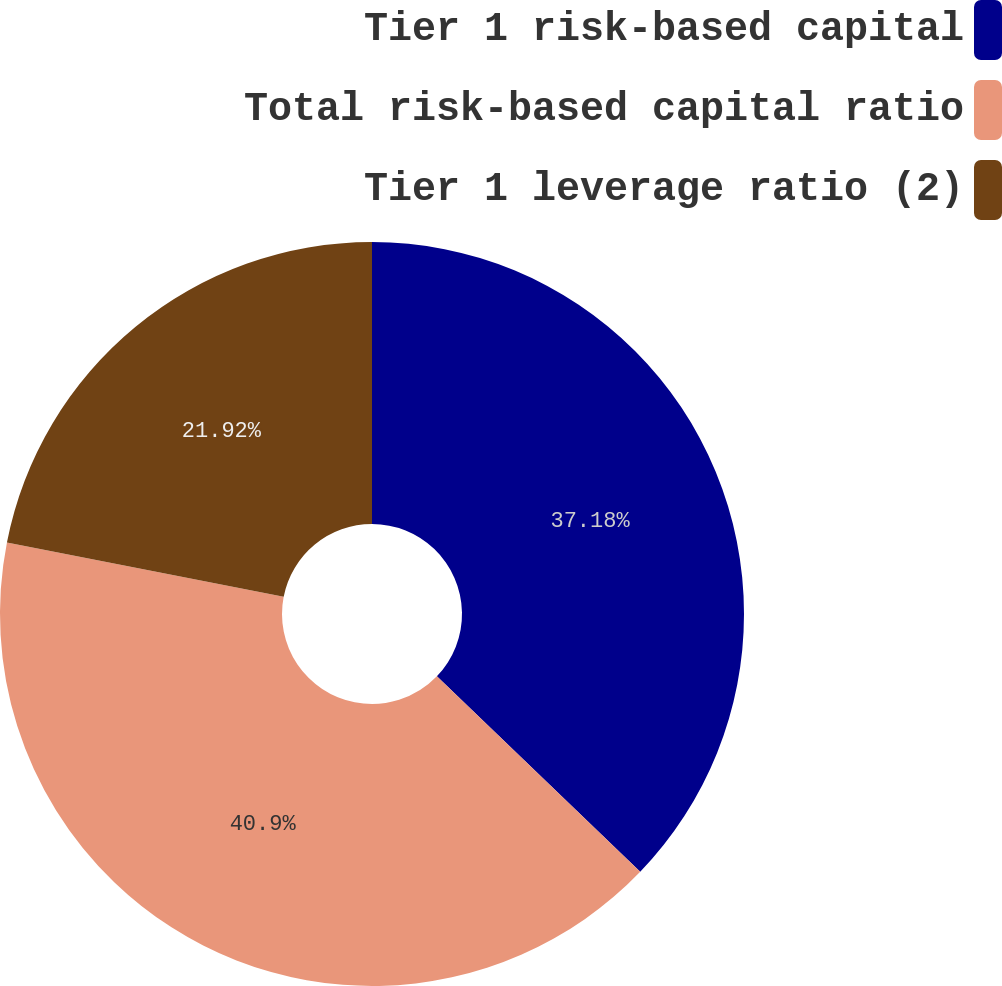<chart> <loc_0><loc_0><loc_500><loc_500><pie_chart><fcel>Tier 1 risk-based capital<fcel>Total risk-based capital ratio<fcel>Tier 1 leverage ratio (2)<nl><fcel>37.18%<fcel>40.89%<fcel>21.92%<nl></chart> 